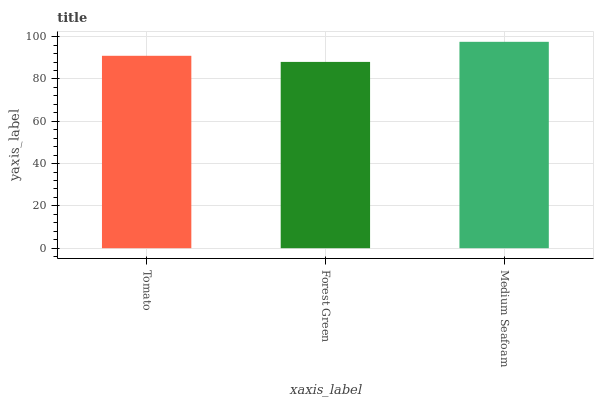Is Forest Green the minimum?
Answer yes or no. Yes. Is Medium Seafoam the maximum?
Answer yes or no. Yes. Is Medium Seafoam the minimum?
Answer yes or no. No. Is Forest Green the maximum?
Answer yes or no. No. Is Medium Seafoam greater than Forest Green?
Answer yes or no. Yes. Is Forest Green less than Medium Seafoam?
Answer yes or no. Yes. Is Forest Green greater than Medium Seafoam?
Answer yes or no. No. Is Medium Seafoam less than Forest Green?
Answer yes or no. No. Is Tomato the high median?
Answer yes or no. Yes. Is Tomato the low median?
Answer yes or no. Yes. Is Medium Seafoam the high median?
Answer yes or no. No. Is Medium Seafoam the low median?
Answer yes or no. No. 